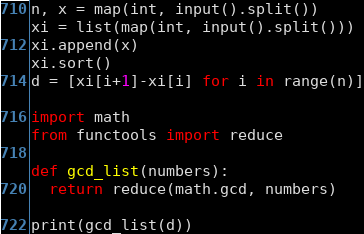Convert code to text. <code><loc_0><loc_0><loc_500><loc_500><_Python_>n, x = map(int, input().split())
xi = list(map(int, input().split()))
xi.append(x)
xi.sort()
d = [xi[i+1]-xi[i] for i in range(n)]

import math
from functools import reduce

def gcd_list(numbers):
  return reduce(math.gcd, numbers)

print(gcd_list(d))</code> 